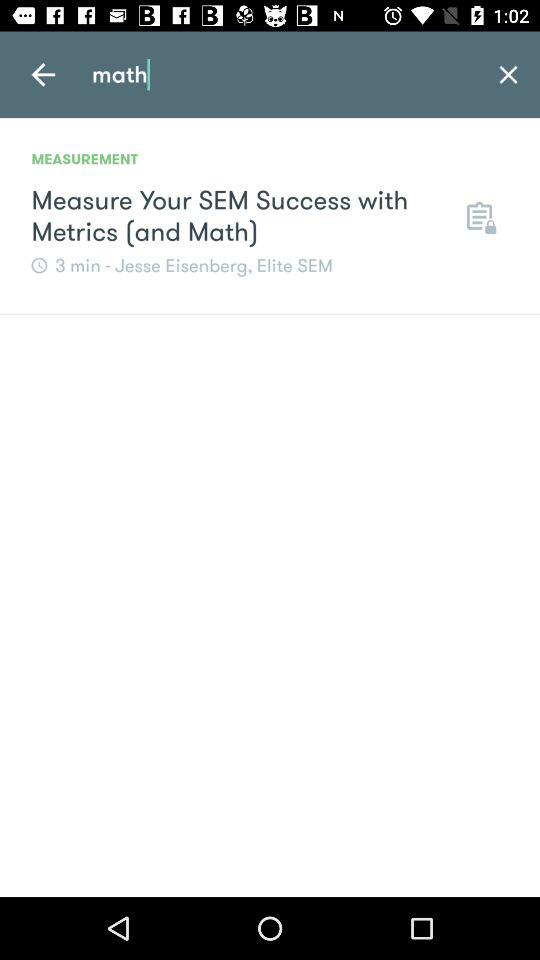What is the given duration? The given duration is 3 minutes. 